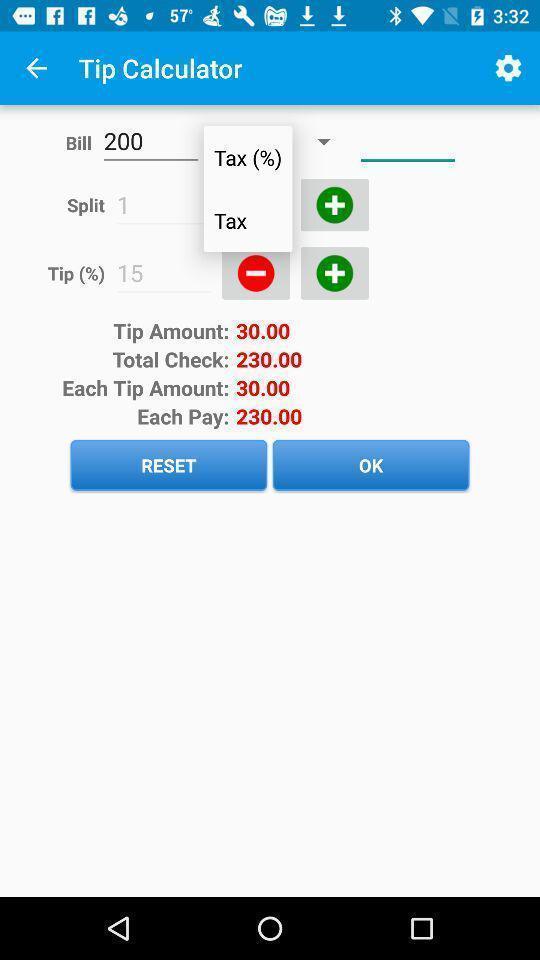Please provide a description for this image. Tip calculator page in a expense tracking app. 